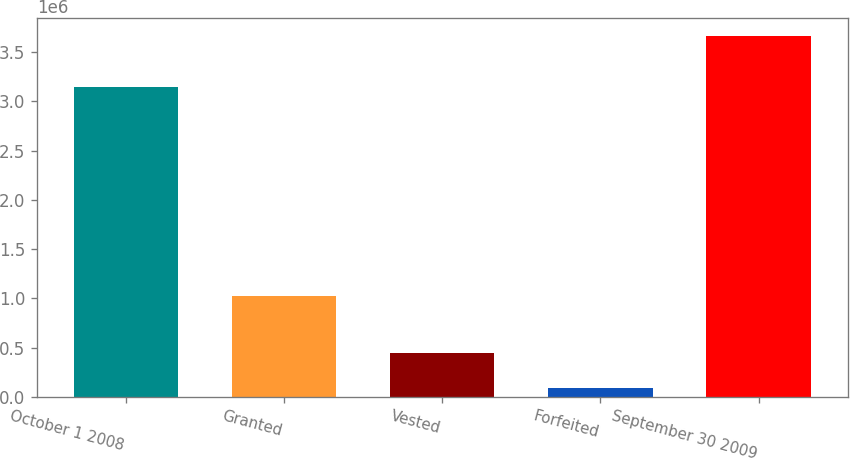<chart> <loc_0><loc_0><loc_500><loc_500><bar_chart><fcel>October 1 2008<fcel>Granted<fcel>Vested<fcel>Forfeited<fcel>September 30 2009<nl><fcel>3.14835e+06<fcel>1.027e+06<fcel>446169<fcel>89064<fcel>3.66011e+06<nl></chart> 